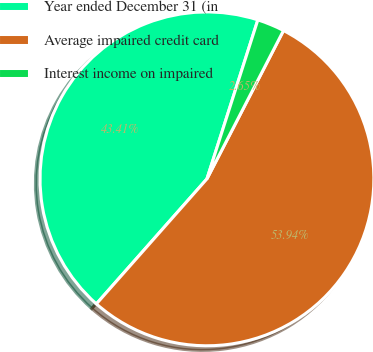Convert chart. <chart><loc_0><loc_0><loc_500><loc_500><pie_chart><fcel>Year ended December 31 (in<fcel>Average impaired credit card<fcel>Interest income on impaired<nl><fcel>43.41%<fcel>53.94%<fcel>2.65%<nl></chart> 